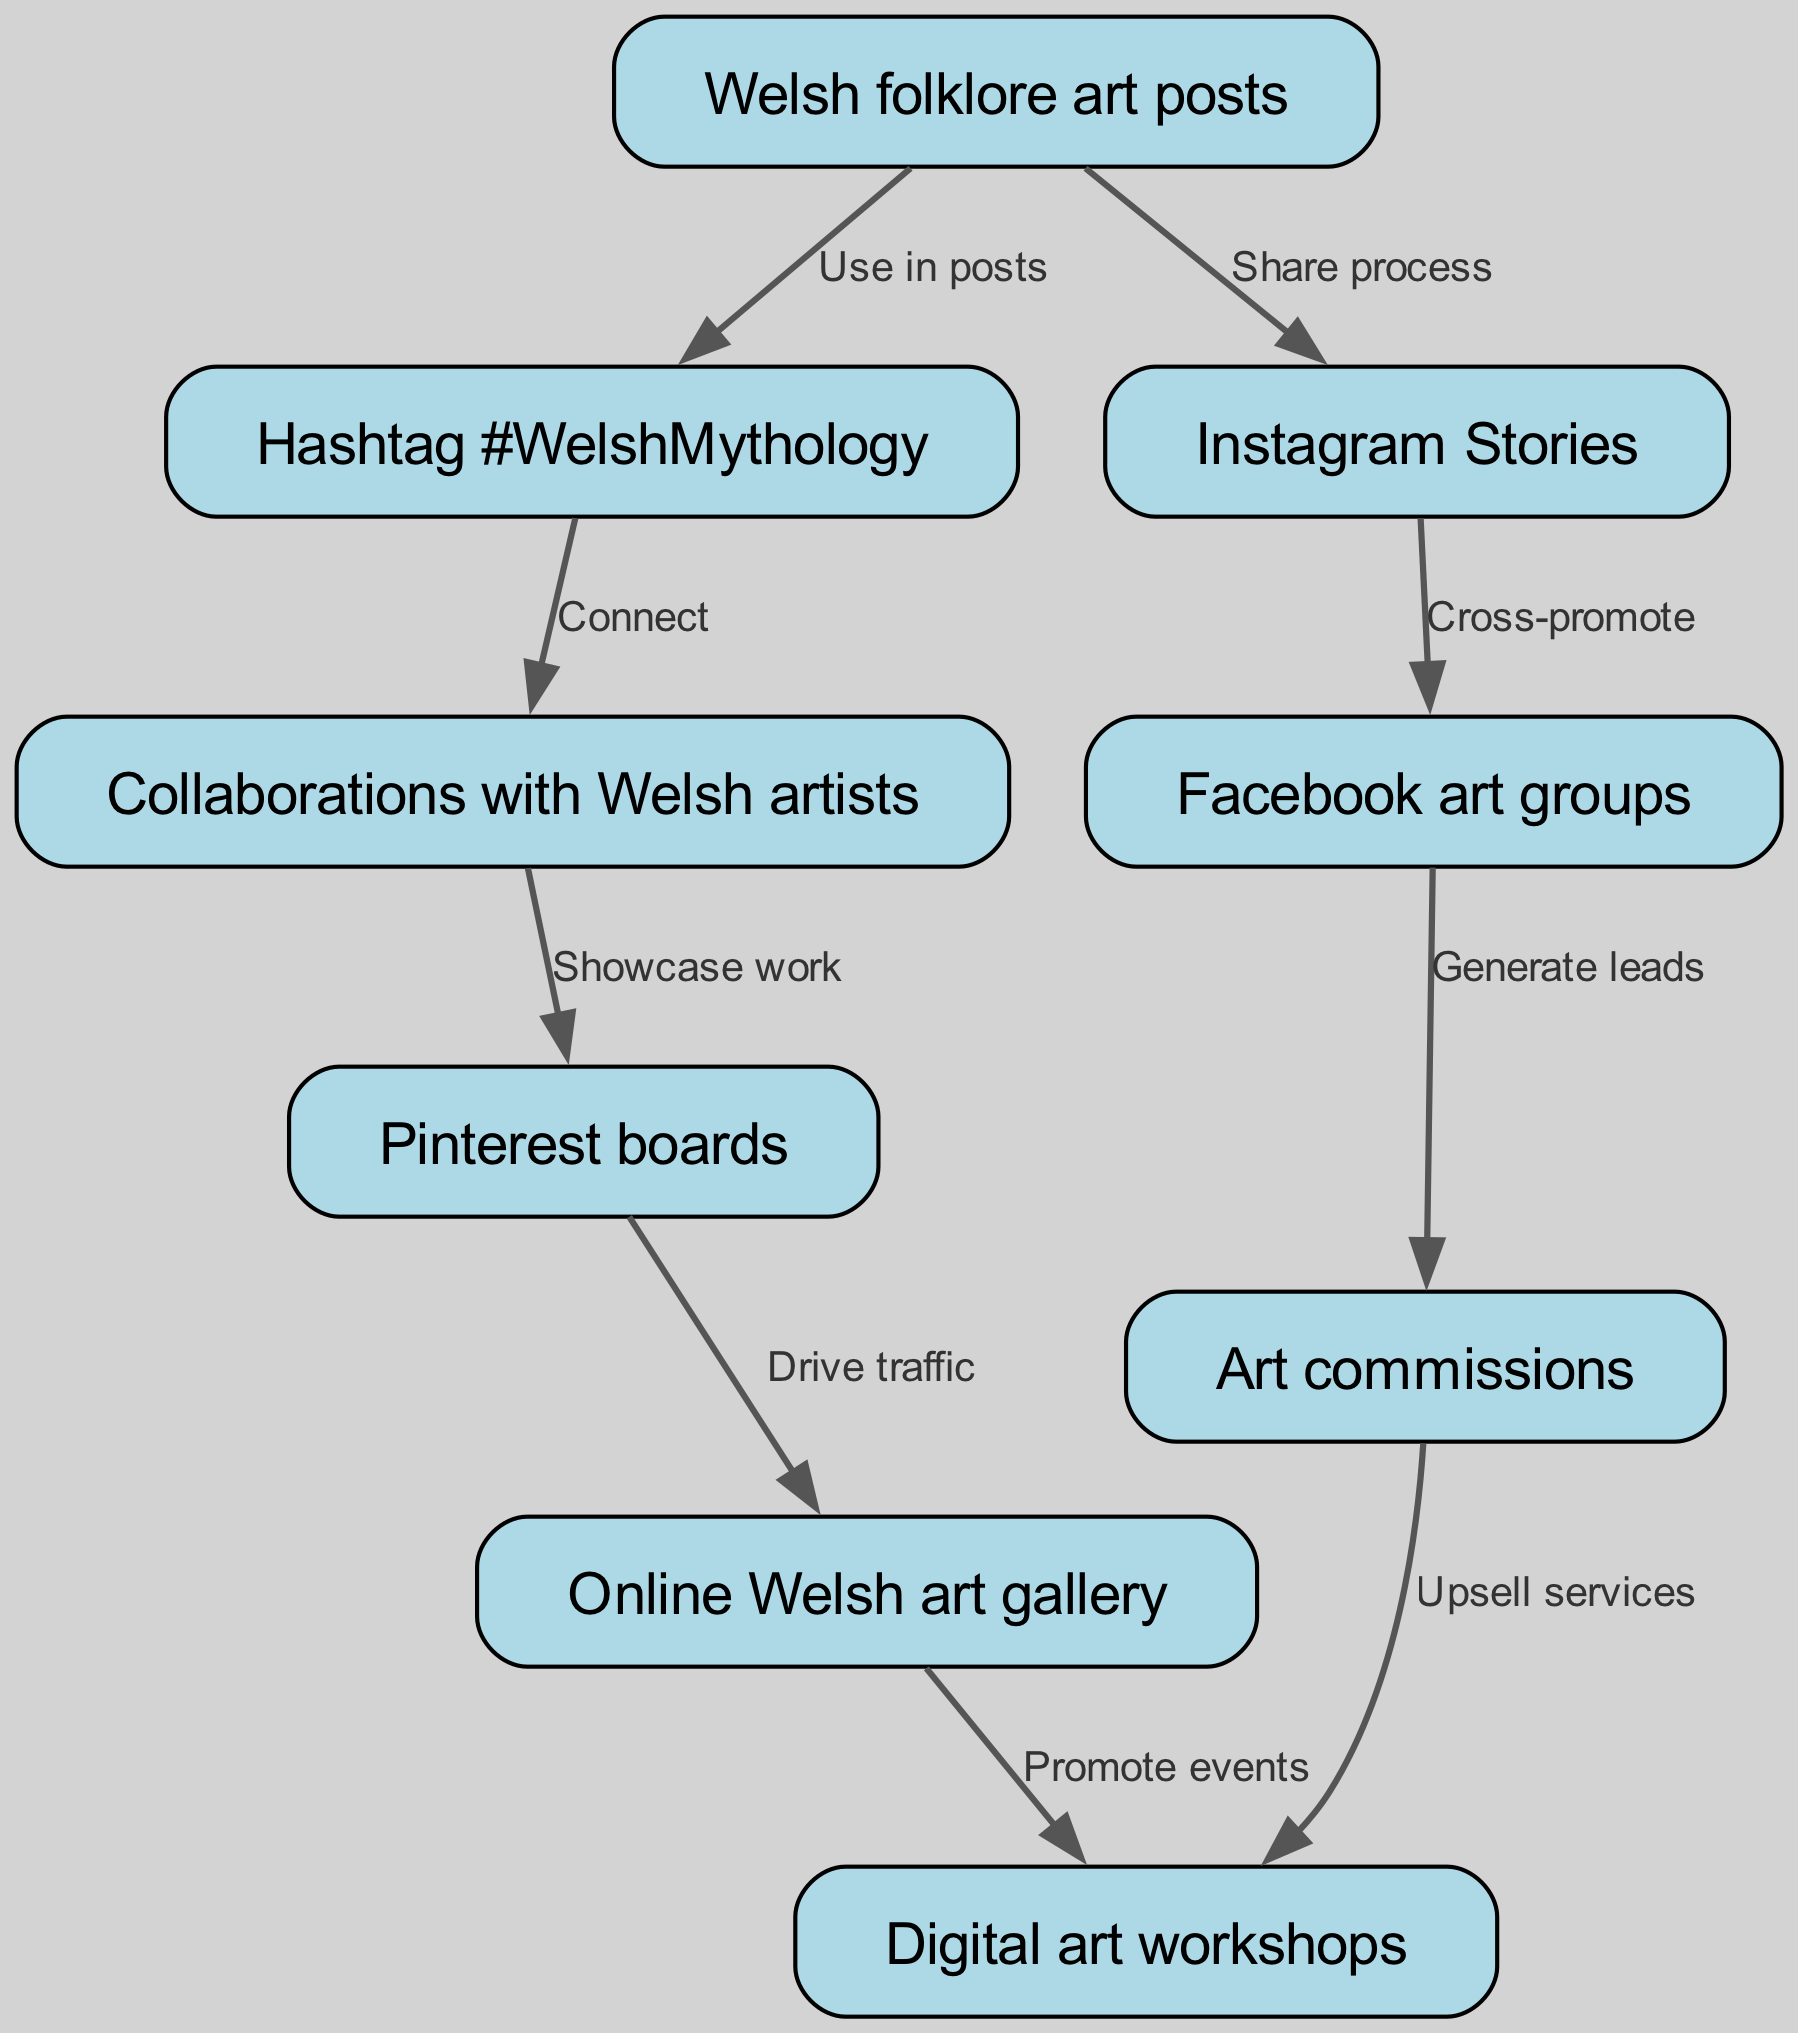What is the starting point node in the diagram? The starting point node is "Welsh folklore art posts," as it does not have any incoming edges and is the initial node in the flow of engagement.
Answer: Welsh folklore art posts How many nodes are present in the diagram? By counting the nodes listed in the data, there are a total of nine different nodes present in the diagram.
Answer: 9 Which nodes connect "Instagram Stories"? The node "Instagram Stories" connects to "Facebook art groups" based on the edge described in the diagram, which indicates that there is a direct interaction between these two nodes.
Answer: Facebook art groups What does "Hashtag #WelshMythology" lead to? "Hashtag #WelshMythology" leads to "Collaborations with Welsh artists," as indicated by the direct edge that shows the connection between these two nodes.
Answer: Collaborations with Welsh artists How many edges stem from "Facebook art groups"? There is one outgoing edge from "Facebook art groups," which goes to "Art commissions," as shown in the diagram's flow.
Answer: 1 What is the relationship between "Pinterest boards" and "Online Welsh art gallery"? The relationship is that "Pinterest boards" drive traffic to "Online Welsh art gallery," as indicated by the directed edge showing this flow of interaction.
Answer: Drive traffic Which node has the most connections leading out from it? The node "Art commissions" has one outgoing edge leading to "Digital art workshops," whereas other nodes may have only one or no outgoing edges, thus having a comparatively lesser number of connections.
Answer: 1 What follows after "Art commissions" in the engagement flow? After "Art commissions," the next node is "Digital art workshops," showing an upselling of services related to art commissions, as indicated by the directed edge.
Answer: Digital art workshops What is an example of a cross-promotion strategy in the diagram? The example of cross-promotion in the diagram is "Instagram Stories" leading to "Facebook art groups," indicating the strategy to promote content across different platforms.
Answer: Cross-promote 